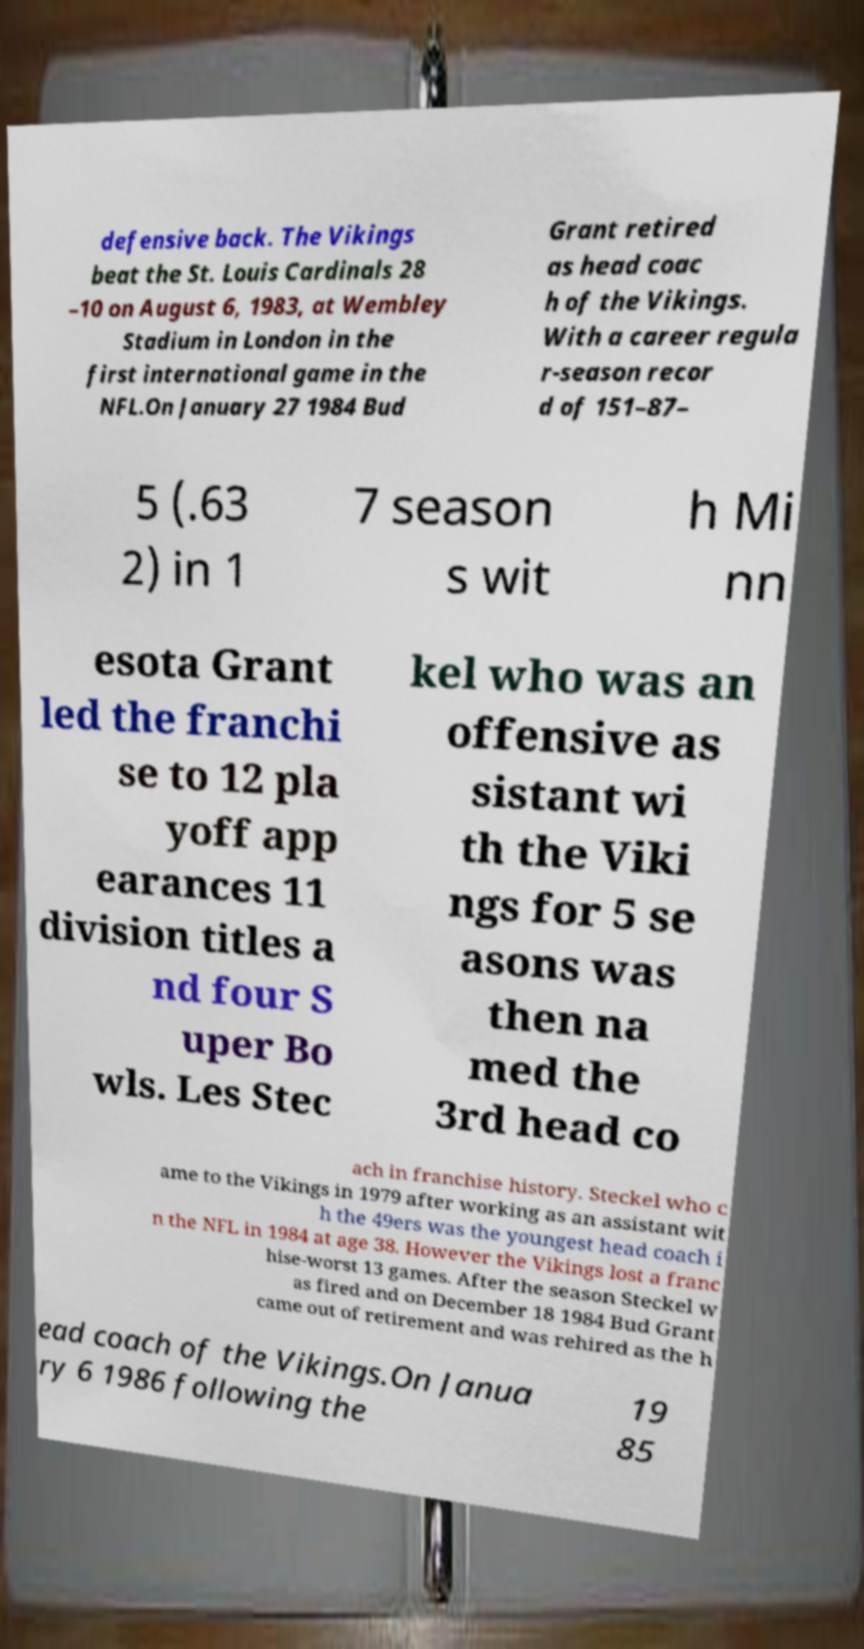For documentation purposes, I need the text within this image transcribed. Could you provide that? defensive back. The Vikings beat the St. Louis Cardinals 28 –10 on August 6, 1983, at Wembley Stadium in London in the first international game in the NFL.On January 27 1984 Bud Grant retired as head coac h of the Vikings. With a career regula r-season recor d of 151–87– 5 (.63 2) in 1 7 season s wit h Mi nn esota Grant led the franchi se to 12 pla yoff app earances 11 division titles a nd four S uper Bo wls. Les Stec kel who was an offensive as sistant wi th the Viki ngs for 5 se asons was then na med the 3rd head co ach in franchise history. Steckel who c ame to the Vikings in 1979 after working as an assistant wit h the 49ers was the youngest head coach i n the NFL in 1984 at age 38. However the Vikings lost a franc hise-worst 13 games. After the season Steckel w as fired and on December 18 1984 Bud Grant came out of retirement and was rehired as the h ead coach of the Vikings.On Janua ry 6 1986 following the 19 85 